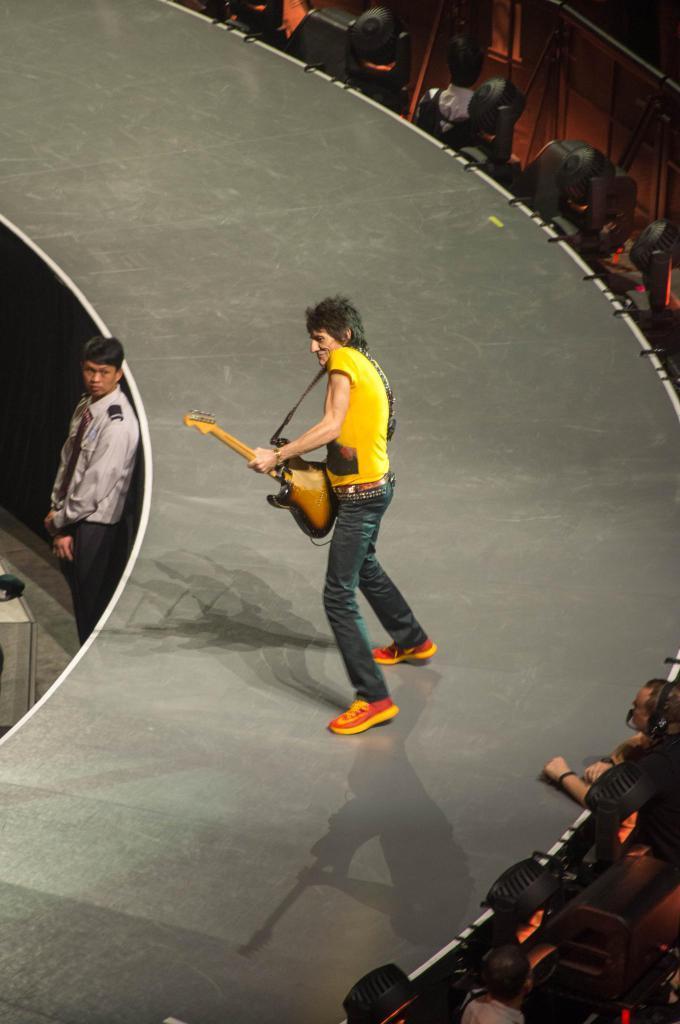How would you summarize this image in a sentence or two? This image is taken indoors. On the right side of the image a few people are sitting on the chairs. In the middle of the image a man is standing on the ramp and playing music with a guitar. At the bottom of the image there is a ramp. On the left side of the image a man is standing on the floor. 